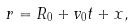Convert formula to latex. <formula><loc_0><loc_0><loc_500><loc_500>r = R _ { 0 } + v _ { 0 } t + x ,</formula> 